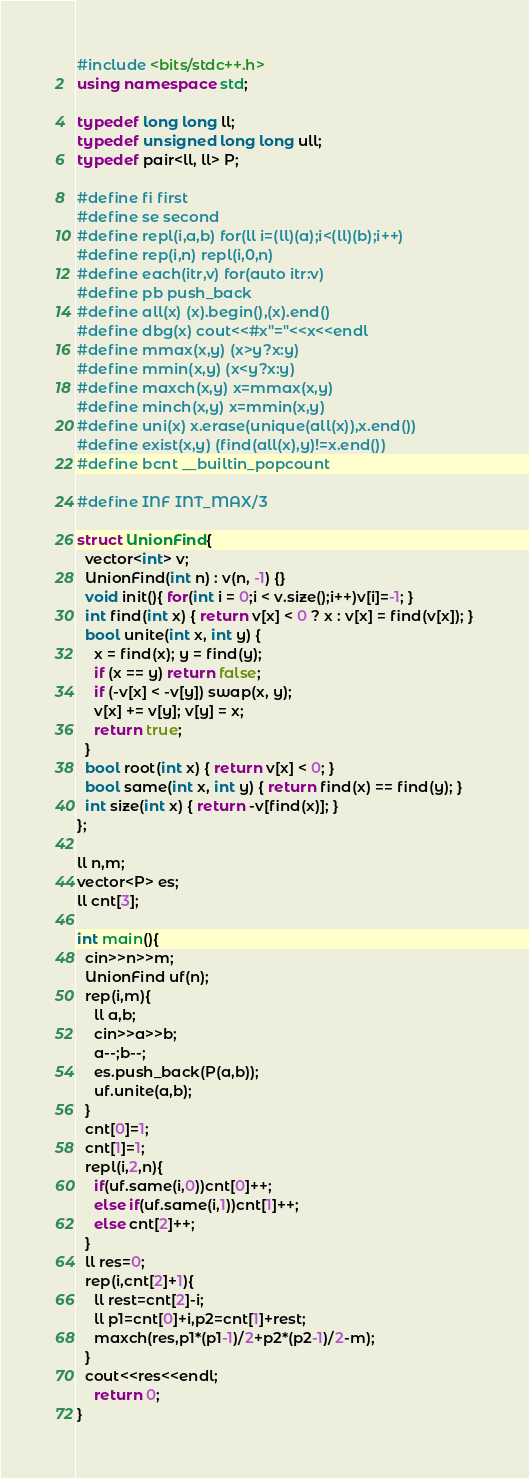Convert code to text. <code><loc_0><loc_0><loc_500><loc_500><_C++_>#include <bits/stdc++.h>
using namespace std;

typedef long long ll;
typedef unsigned long long ull;
typedef pair<ll, ll> P;

#define fi first
#define se second
#define repl(i,a,b) for(ll i=(ll)(a);i<(ll)(b);i++)
#define rep(i,n) repl(i,0,n)
#define each(itr,v) for(auto itr:v)
#define pb push_back
#define all(x) (x).begin(),(x).end()
#define dbg(x) cout<<#x"="<<x<<endl
#define mmax(x,y) (x>y?x:y)
#define mmin(x,y) (x<y?x:y)
#define maxch(x,y) x=mmax(x,y)
#define minch(x,y) x=mmin(x,y)
#define uni(x) x.erase(unique(all(x)),x.end())
#define exist(x,y) (find(all(x),y)!=x.end())
#define bcnt __builtin_popcount

#define INF INT_MAX/3

struct UnionFind{
  vector<int> v;
  UnionFind(int n) : v(n, -1) {}
  void init(){ for(int i = 0;i < v.size();i++)v[i]=-1; }
  int find(int x) { return v[x] < 0 ? x : v[x] = find(v[x]); }
  bool unite(int x, int y) {
    x = find(x); y = find(y);
    if (x == y) return false;
    if (-v[x] < -v[y]) swap(x, y);
    v[x] += v[y]; v[y] = x;
    return true;
  }
  bool root(int x) { return v[x] < 0; }
  bool same(int x, int y) { return find(x) == find(y); }
  int size(int x) { return -v[find(x)]; }
};

ll n,m;
vector<P> es;
ll cnt[3];

int main(){
  cin>>n>>m;
  UnionFind uf(n);
  rep(i,m){
    ll a,b;
    cin>>a>>b;
    a--;b--;
    es.push_back(P(a,b));
    uf.unite(a,b);
  }
  cnt[0]=1;
  cnt[1]=1;
  repl(i,2,n){
    if(uf.same(i,0))cnt[0]++;
    else if(uf.same(i,1))cnt[1]++;
    else cnt[2]++;
  }
  ll res=0;
  rep(i,cnt[2]+1){
    ll rest=cnt[2]-i;
    ll p1=cnt[0]+i,p2=cnt[1]+rest;
    maxch(res,p1*(p1-1)/2+p2*(p2-1)/2-m);
  }
  cout<<res<<endl;
	return 0;
}
</code> 